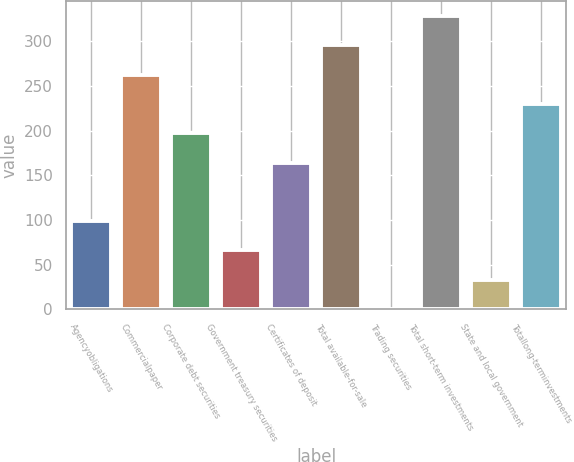Convert chart to OTSL. <chart><loc_0><loc_0><loc_500><loc_500><bar_chart><fcel>Agencyobligations<fcel>Commercialpaper<fcel>Corporate debt securities<fcel>Government treasury securities<fcel>Certificates of deposit<fcel>Total available-for-sale<fcel>Trading securities<fcel>Total short-term investments<fcel>State and local government<fcel>Totallong-terminvestments<nl><fcel>98.51<fcel>262.46<fcel>196.88<fcel>65.72<fcel>164.09<fcel>295.25<fcel>0.14<fcel>328.04<fcel>32.93<fcel>229.67<nl></chart> 